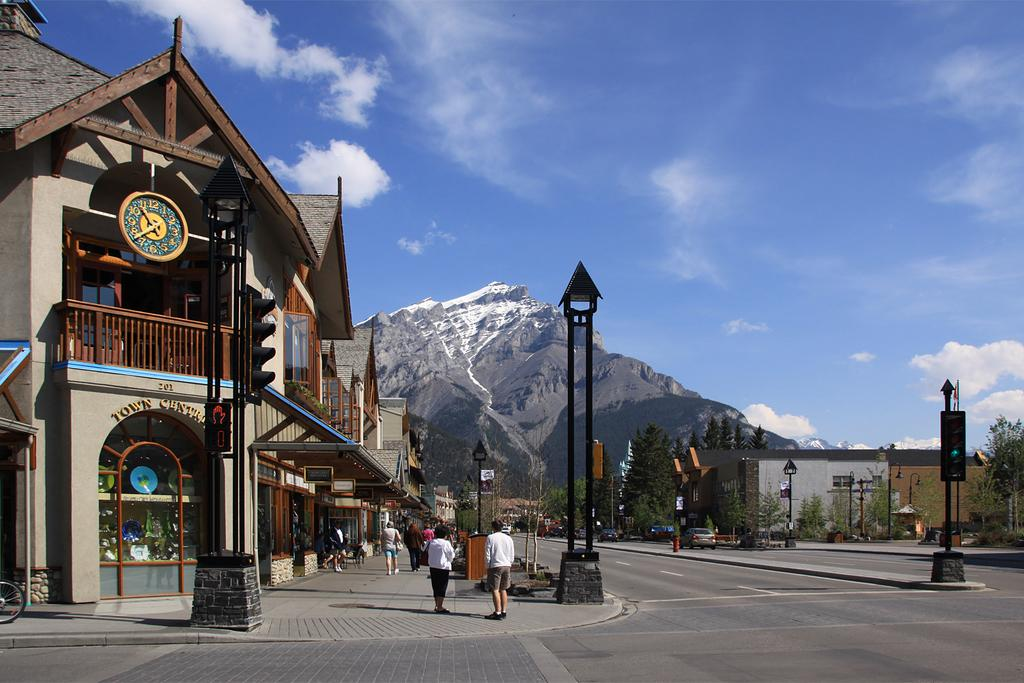What type of structure is present in the image? There is a building in the image. What feature is present on the building? The building has a clock. What type of barrier can be seen in the image? There is a fence in the image. What vertical structures are present in the image? There are poles in the image. What type of vegetation is visible in the image? There are trees in the image. Are there any living beings in the image? Yes, there are people in the image. Can you describe any other unspecified elements in the image? There are other unspecified things in the image. What type of fuel is being used by the lumber in the image? There is no lumber or fuel present in the image. How many items can be found in the person's pocket in the image? There is no mention of a pocket or any items in a pocket in the image. 